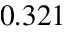<formula> <loc_0><loc_0><loc_500><loc_500>0 . 3 2 1</formula> 